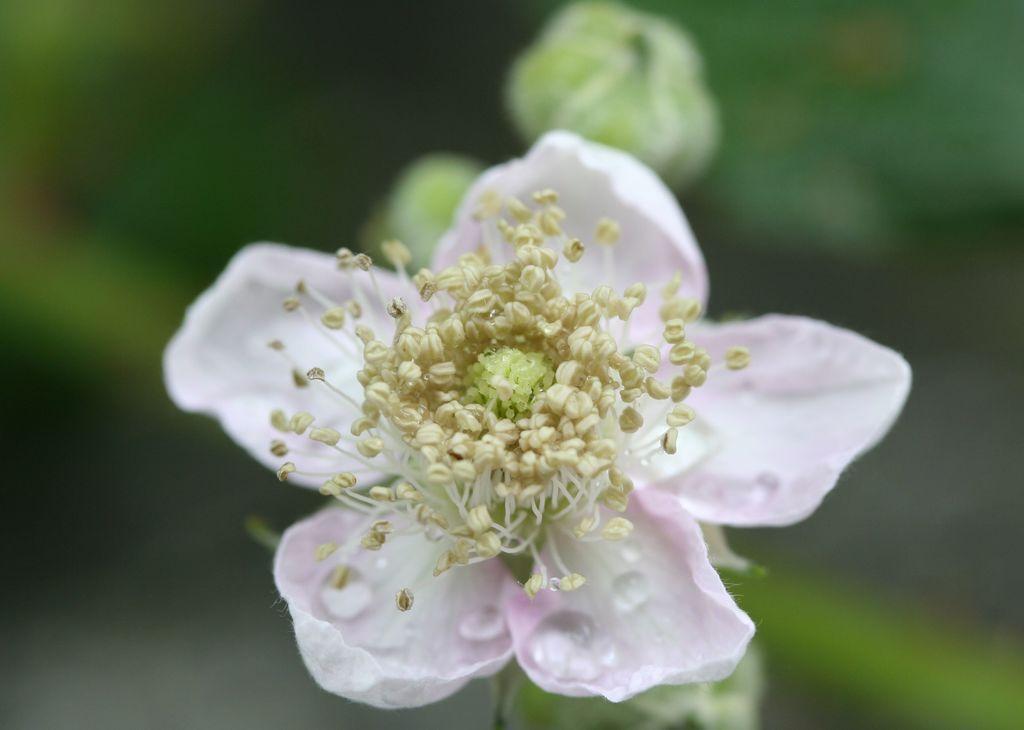In one or two sentences, can you explain what this image depicts? In this image we can see a flower which is in pink and yellow color and in the background image is blur. 